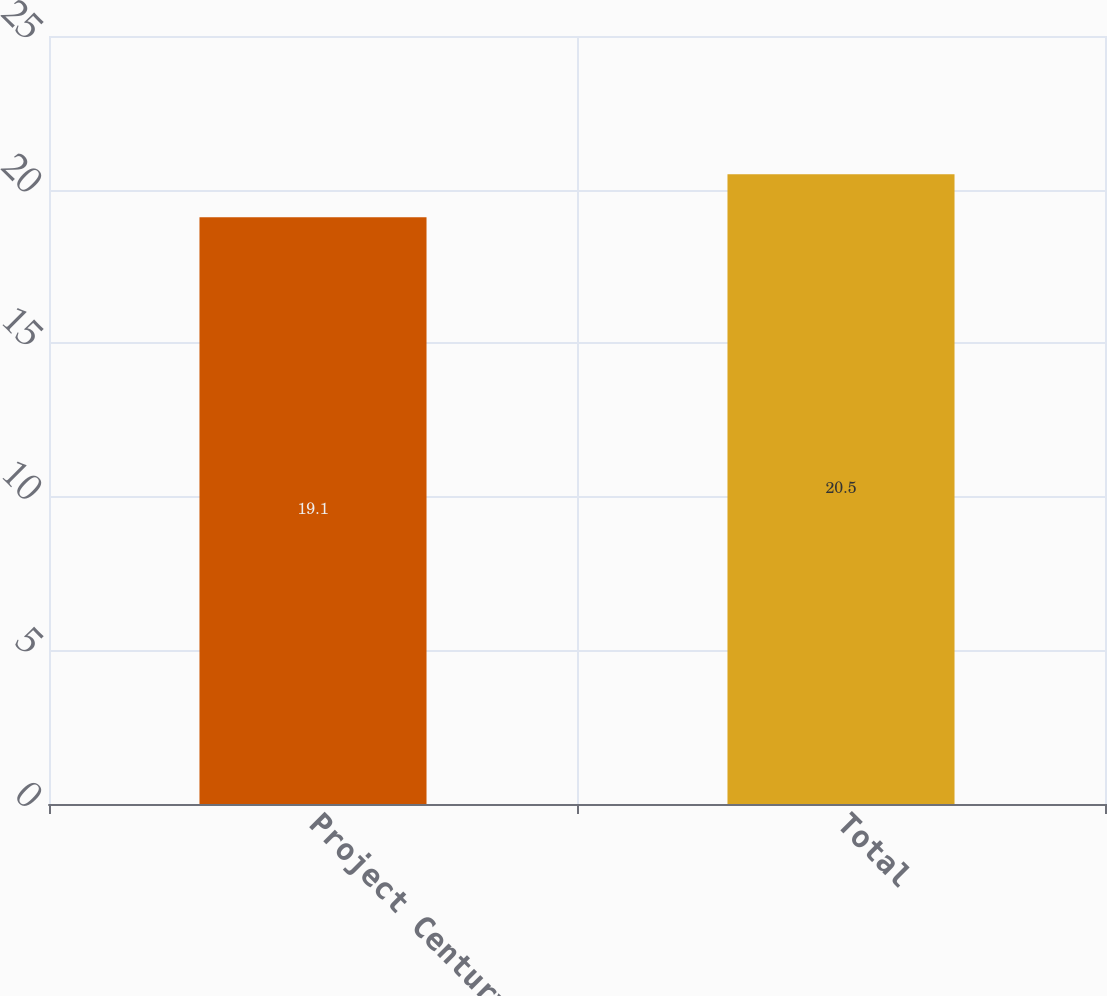<chart> <loc_0><loc_0><loc_500><loc_500><bar_chart><fcel>Project Century<fcel>Total<nl><fcel>19.1<fcel>20.5<nl></chart> 